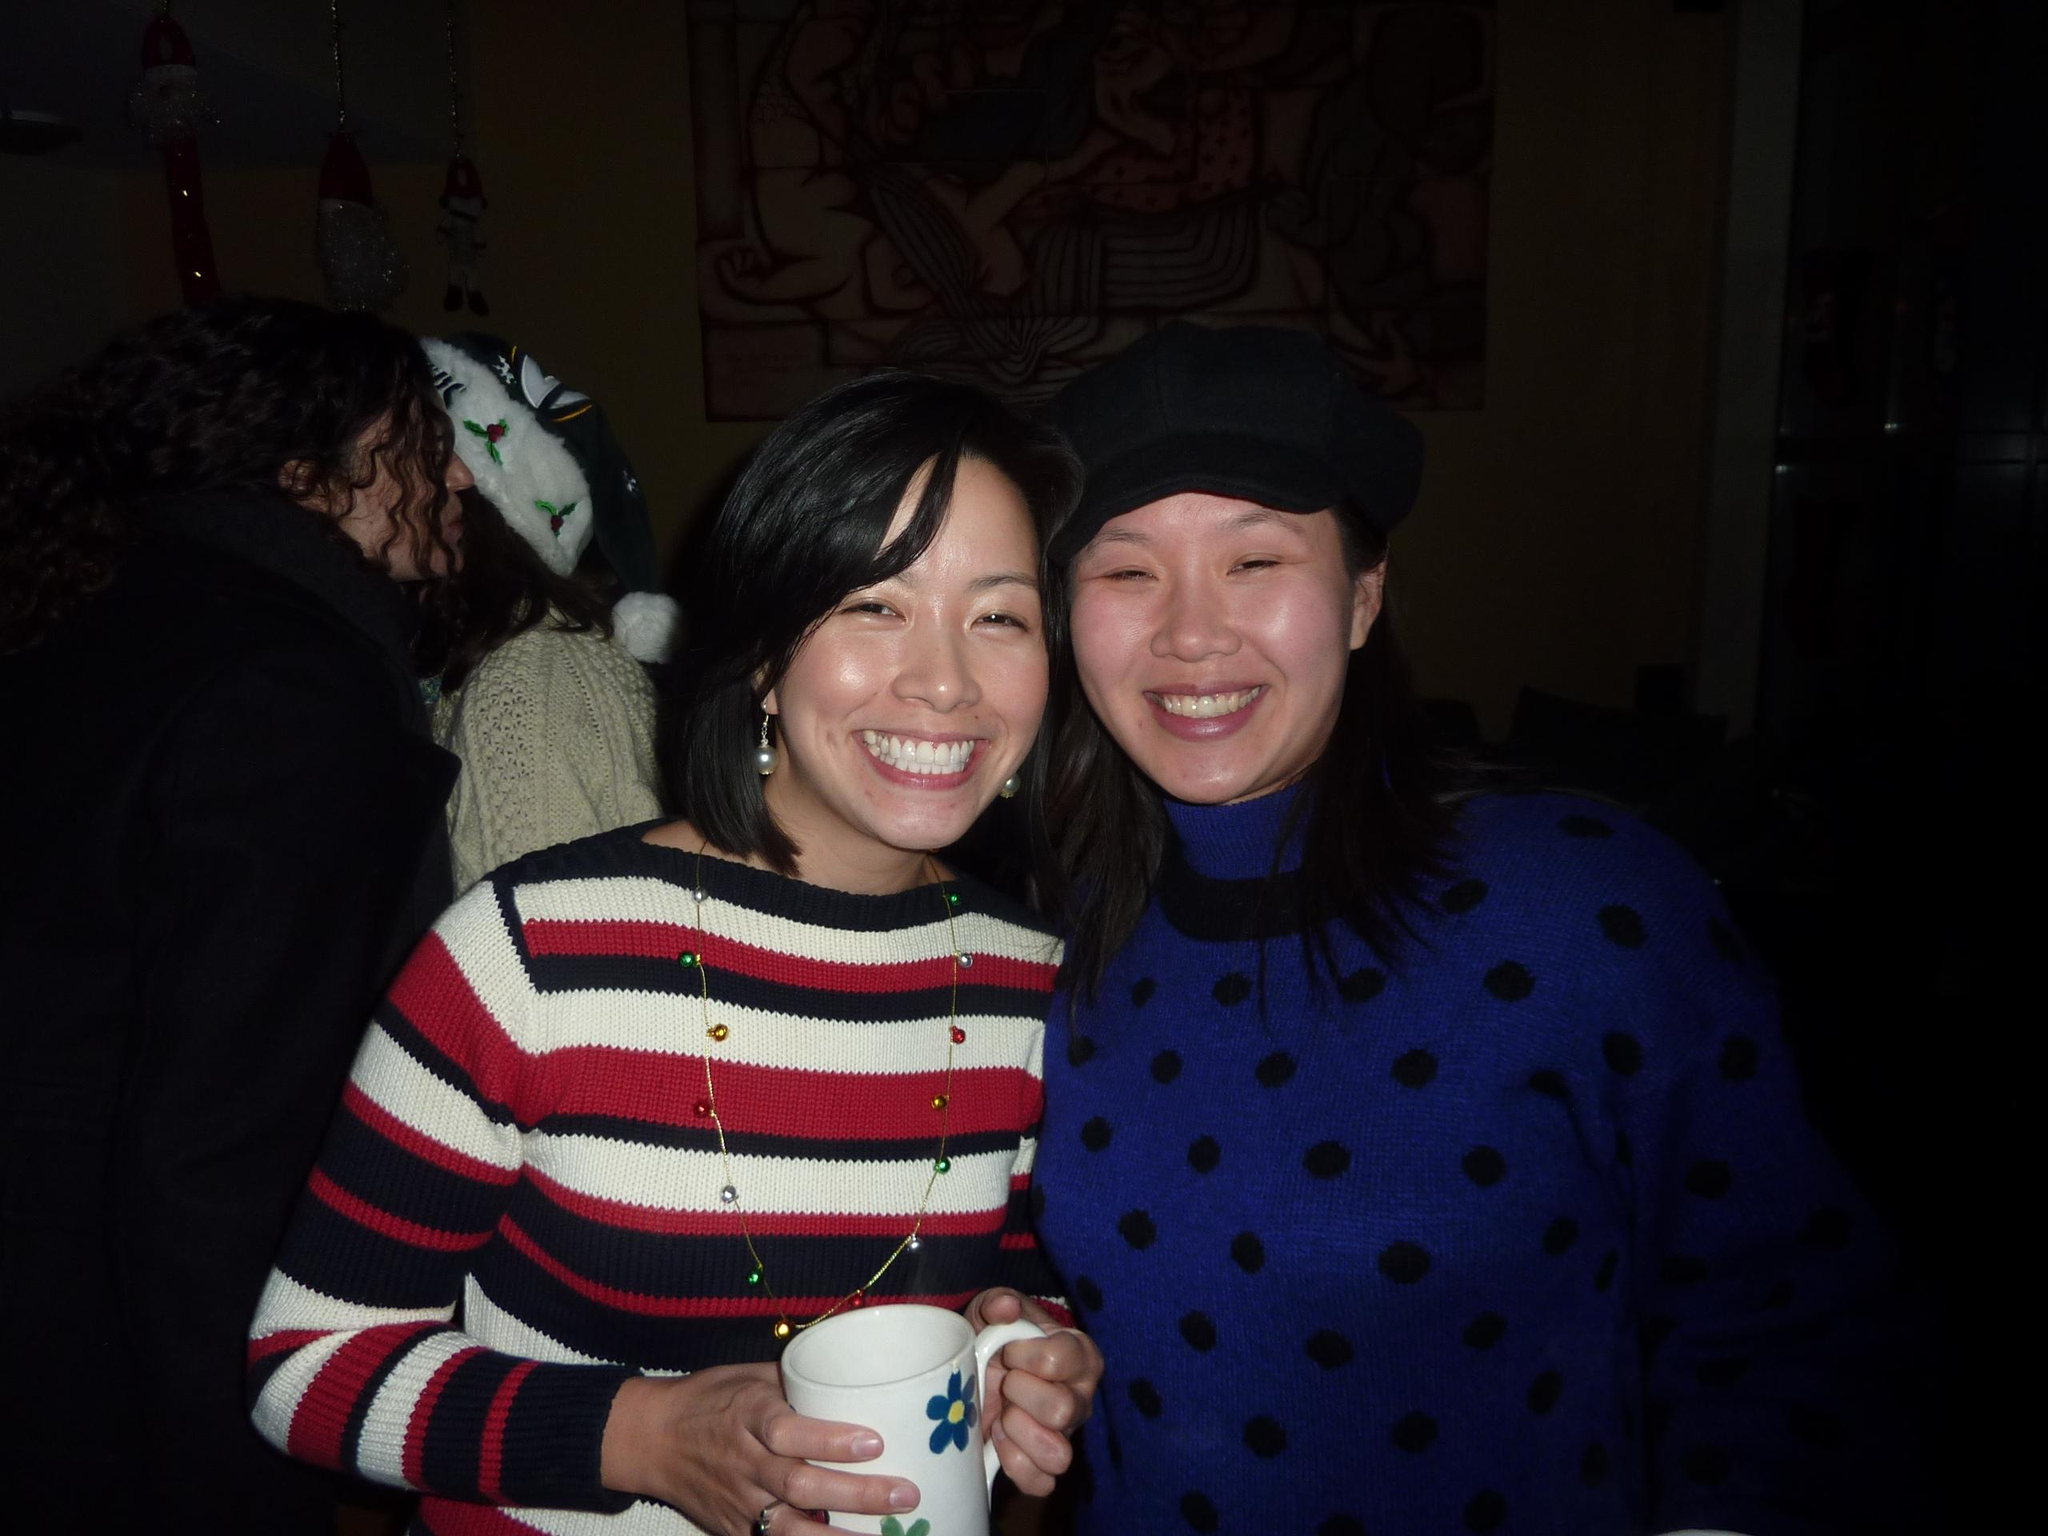How many women are in the image? There are two women in the image. What is one of the women holding? One of the women is holding a cup in her hands. What expression do the women have? Both women are smiling. Can you describe the background of the image? The background of the image is dark, and there are people visible. What type of fish can be seen swimming in the cup held by one of the women? There is no fish visible in the image; one of the women is holding a cup, but it is not specified what is inside the cup. 